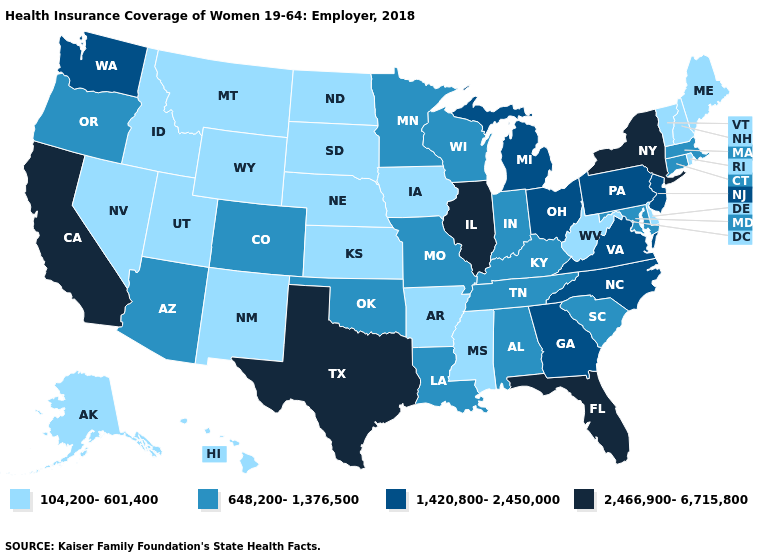Among the states that border Maryland , which have the lowest value?
Answer briefly. Delaware, West Virginia. Does Alabama have a higher value than Louisiana?
Give a very brief answer. No. Name the states that have a value in the range 1,420,800-2,450,000?
Answer briefly. Georgia, Michigan, New Jersey, North Carolina, Ohio, Pennsylvania, Virginia, Washington. Name the states that have a value in the range 2,466,900-6,715,800?
Concise answer only. California, Florida, Illinois, New York, Texas. Does California have the highest value in the West?
Concise answer only. Yes. Does Missouri have a higher value than South Dakota?
Concise answer only. Yes. What is the value of Minnesota?
Answer briefly. 648,200-1,376,500. Does Pennsylvania have a lower value than New Mexico?
Concise answer only. No. What is the value of Colorado?
Answer briefly. 648,200-1,376,500. Among the states that border Georgia , does Alabama have the highest value?
Concise answer only. No. What is the value of North Carolina?
Short answer required. 1,420,800-2,450,000. What is the value of Maine?
Short answer required. 104,200-601,400. What is the lowest value in the MidWest?
Give a very brief answer. 104,200-601,400. What is the value of Illinois?
Short answer required. 2,466,900-6,715,800. What is the value of Kansas?
Answer briefly. 104,200-601,400. 